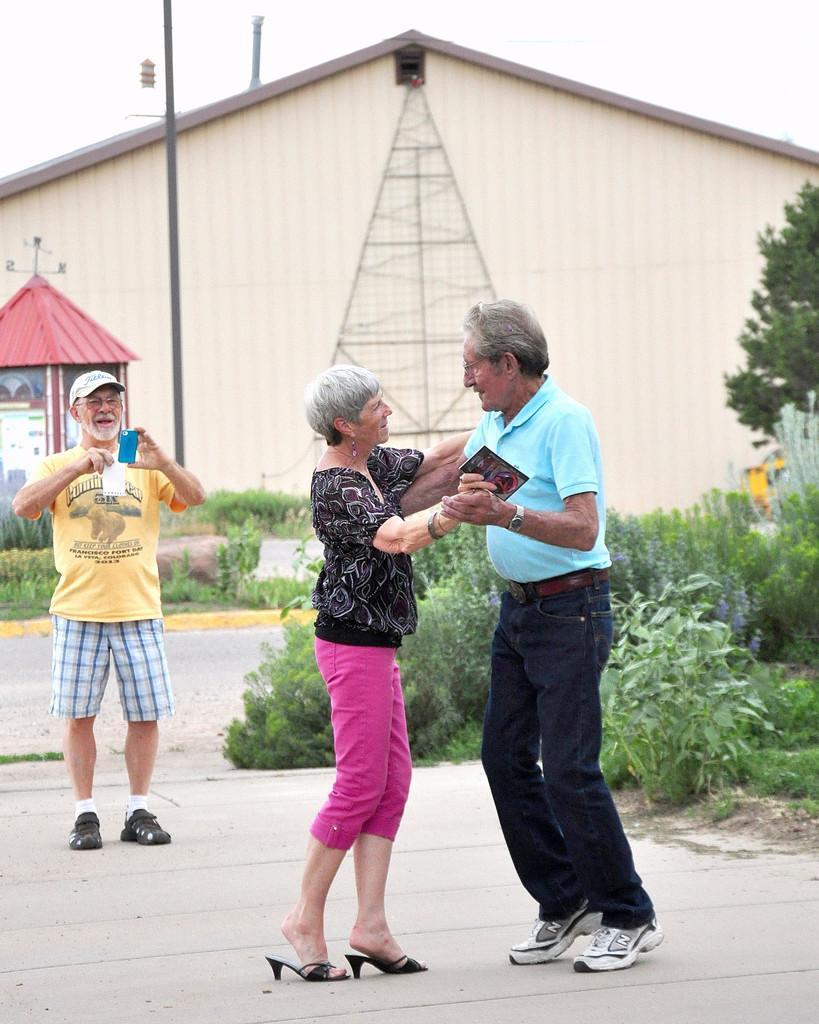In one or two sentences, can you explain what this image depicts? In this image there are three people in which one of them holds a mobile phone and capturing a photo, there is a house, poles, plants, trees, a booth and the sky. 